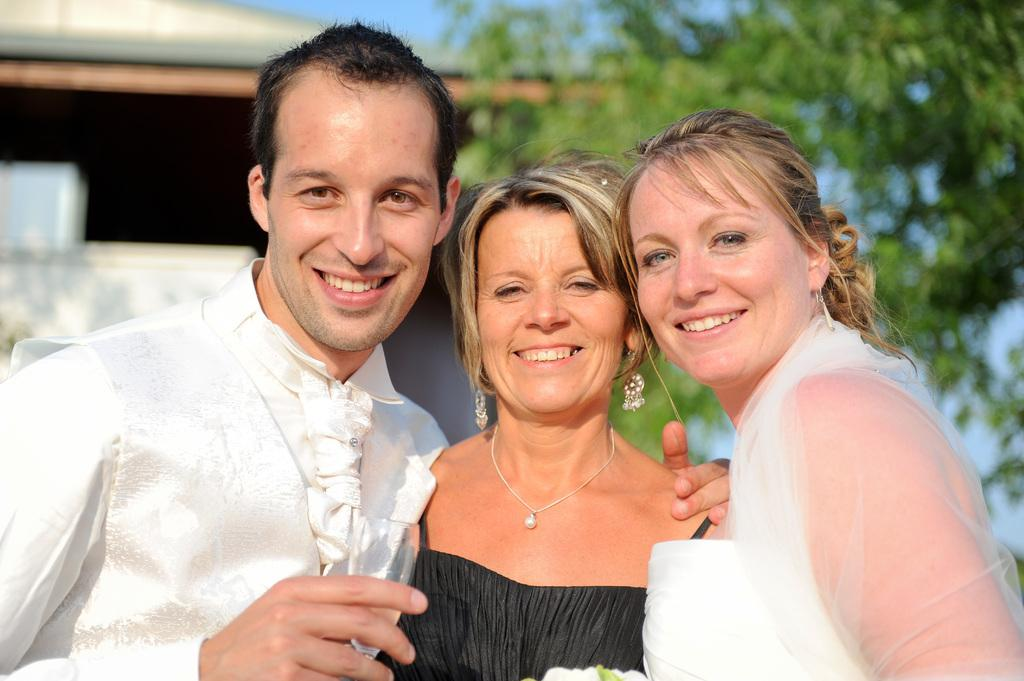What are the people in the image doing? The people in the image are standing and smiling. Can you describe what one person is holding? One person is holding a glass. What can be seen in the background of the image? There are trees and a shed in the background of the image. What type of shirt is being exchanged between the people in the image? There is no shirt exchange happening in the image; the people are simply standing and smiling. 